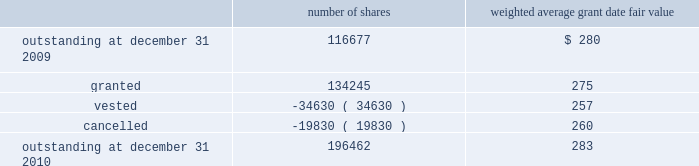The company granted 1020 performance shares .
The vesting of these shares is contingent on meeting stated goals over a performance period .
Beginning with restricted stock grants in september 2010 , dividends are accrued on restricted class a common stock and restricted stock units and are paid once the restricted stock vests .
The table summarizes restricted stock and performance shares activity for 2010 : number of shares weighted average grant date fair value .
The total fair value of restricted stock that vested during the years ended december 31 , 2010 , 2009 and 2008 , was $ 10.3 million , $ 6.2 million and $ 2.5 million , respectively .
Eligible employees may acquire shares of cme group 2019s class a common stock using after-tax payroll deductions made during consecutive offering periods of approximately six months in duration .
Shares are purchased at the end of each offering period at a price of 90% ( 90 % ) of the closing price of the class a common stock as reported on the nasdaq .
Compensation expense is recognized on the dates of purchase for the discount from the closing price .
In 2010 , 2009 and 2008 , a total of 4371 , 4402 and 5600 shares , respectively , of class a common stock were issued to participating employees .
These shares are subject to a six-month holding period .
Annual expense of $ 0.1 million for the purchase discount was recognized in 2010 , 2009 and 2008 , respectively .
Non-executive directors receive an annual award of class a common stock with a value equal to $ 75000 .
Non-executive directors may also elect to receive some or all of the cash portion of their annual stipend , up to $ 25000 , in shares of stock based on the closing price at the date of distribution .
As a result , 7470 , 11674 and 5509 shares of class a common stock were issued to non-executive directors during 2010 , 2009 and 2008 , respectively .
These shares are not subject to any vesting restrictions .
Expense of $ 2.4 million , $ 2.5 million and $ 2.4 million related to these stock-based payments was recognized for the years ended december 31 , 2010 , 2009 and 2008 , respectively. .
For 2010 , given the class a common stock issued to non-executive directors and the recognized expense , what is the approximate deemed fair value per share at date of issuance? 
Computations: ((2.4 * 1000000) / 7470)
Answer: 321.28514. 